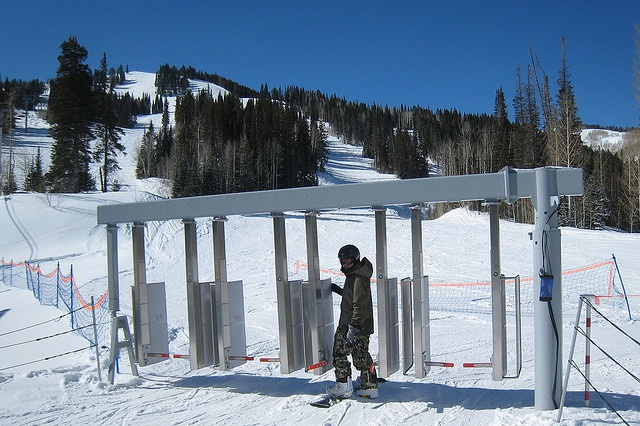Describe the objects in this image and their specific colors. I can see people in blue, black, gray, lightgray, and darkgray tones, skis in blue, gray, and darkgray tones, and snowboard in blue, black, gray, and navy tones in this image. 